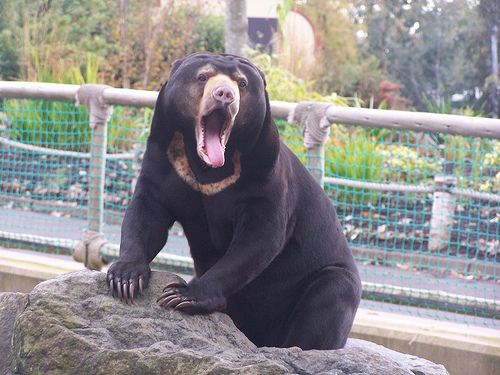<image>
Is there a bear head above the rock? Yes. The bear head is positioned above the rock in the vertical space, higher up in the scene. Is there a bear in front of the fence? Yes. The bear is positioned in front of the fence, appearing closer to the camera viewpoint. 